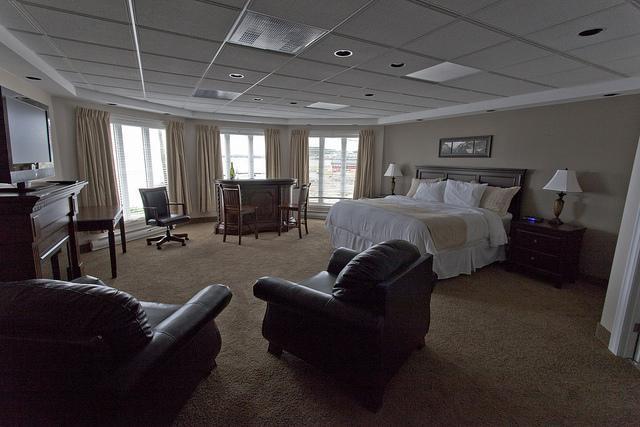How many people can be seated in this room?
Give a very brief answer. 5. How many chairs are there?
Give a very brief answer. 5. How many chairs can you see?
Give a very brief answer. 2. How many couches are there?
Give a very brief answer. 2. How many dogs are in the water?
Give a very brief answer. 0. 